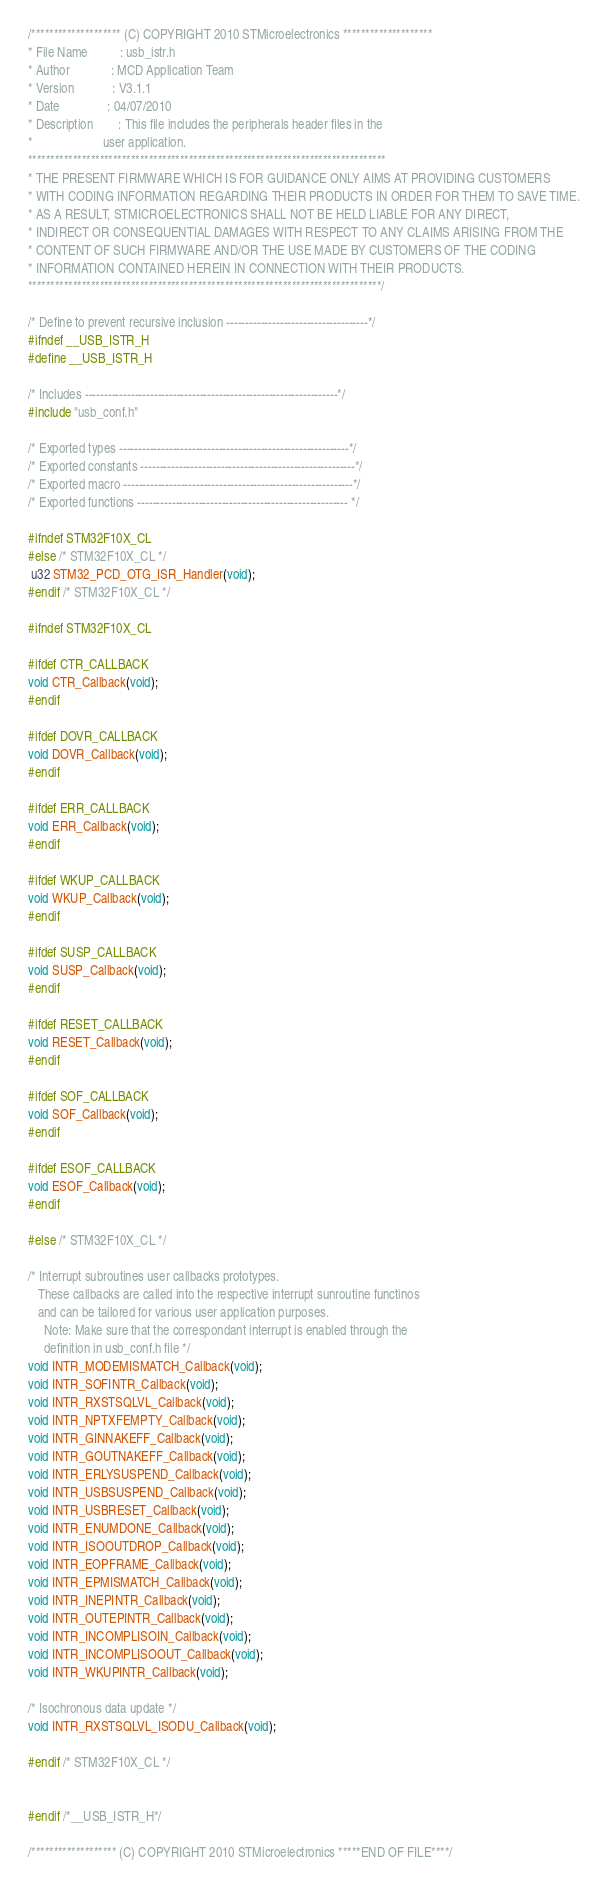Convert code to text. <code><loc_0><loc_0><loc_500><loc_500><_C_>/******************** (C) COPYRIGHT 2010 STMicroelectronics ********************
* File Name          : usb_istr.h
* Author             : MCD Application Team
* Version            : V3.1.1
* Date               : 04/07/2010
* Description        : This file includes the peripherals header files in the
*                      user application.
********************************************************************************
* THE PRESENT FIRMWARE WHICH IS FOR GUIDANCE ONLY AIMS AT PROVIDING CUSTOMERS
* WITH CODING INFORMATION REGARDING THEIR PRODUCTS IN ORDER FOR THEM TO SAVE TIME.
* AS A RESULT, STMICROELECTRONICS SHALL NOT BE HELD LIABLE FOR ANY DIRECT,
* INDIRECT OR CONSEQUENTIAL DAMAGES WITH RESPECT TO ANY CLAIMS ARISING FROM THE
* CONTENT OF SUCH FIRMWARE AND/OR THE USE MADE BY CUSTOMERS OF THE CODING
* INFORMATION CONTAINED HEREIN IN CONNECTION WITH THEIR PRODUCTS.
*******************************************************************************/

/* Define to prevent recursive inclusion -------------------------------------*/
#ifndef __USB_ISTR_H
#define __USB_ISTR_H

/* Includes ------------------------------------------------------------------*/
#include "usb_conf.h"

/* Exported types ------------------------------------------------------------*/
/* Exported constants --------------------------------------------------------*/
/* Exported macro ------------------------------------------------------------*/
/* Exported functions ------------------------------------------------------- */

#ifndef STM32F10X_CL
#else /* STM32F10X_CL */
 u32 STM32_PCD_OTG_ISR_Handler(void);
#endif /* STM32F10X_CL */

#ifndef STM32F10X_CL

#ifdef CTR_CALLBACK
void CTR_Callback(void);
#endif

#ifdef DOVR_CALLBACK
void DOVR_Callback(void);
#endif

#ifdef ERR_CALLBACK
void ERR_Callback(void);
#endif

#ifdef WKUP_CALLBACK
void WKUP_Callback(void);
#endif

#ifdef SUSP_CALLBACK
void SUSP_Callback(void);
#endif

#ifdef RESET_CALLBACK
void RESET_Callback(void);
#endif

#ifdef SOF_CALLBACK
void SOF_Callback(void);
#endif

#ifdef ESOF_CALLBACK
void ESOF_Callback(void);
#endif

#else /* STM32F10X_CL */

/* Interrupt subroutines user callbacks prototypes.
   These callbacks are called into the respective interrupt sunroutine functinos
   and can be tailored for various user application purposes.
     Note: Make sure that the correspondant interrupt is enabled through the 
     definition in usb_conf.h file */ 
void INTR_MODEMISMATCH_Callback(void);
void INTR_SOFINTR_Callback(void);
void INTR_RXSTSQLVL_Callback(void);
void INTR_NPTXFEMPTY_Callback(void);
void INTR_GINNAKEFF_Callback(void);
void INTR_GOUTNAKEFF_Callback(void);
void INTR_ERLYSUSPEND_Callback(void);
void INTR_USBSUSPEND_Callback(void);
void INTR_USBRESET_Callback(void);
void INTR_ENUMDONE_Callback(void);
void INTR_ISOOUTDROP_Callback(void);
void INTR_EOPFRAME_Callback(void);
void INTR_EPMISMATCH_Callback(void);
void INTR_INEPINTR_Callback(void);
void INTR_OUTEPINTR_Callback(void);
void INTR_INCOMPLISOIN_Callback(void);
void INTR_INCOMPLISOOUT_Callback(void);
void INTR_WKUPINTR_Callback(void);

/* Isochronous data update */
void INTR_RXSTSQLVL_ISODU_Callback(void); 

#endif /* STM32F10X_CL */


#endif /*__USB_ISTR_H*/

/******************* (C) COPYRIGHT 2010 STMicroelectronics *****END OF FILE****/
</code> 